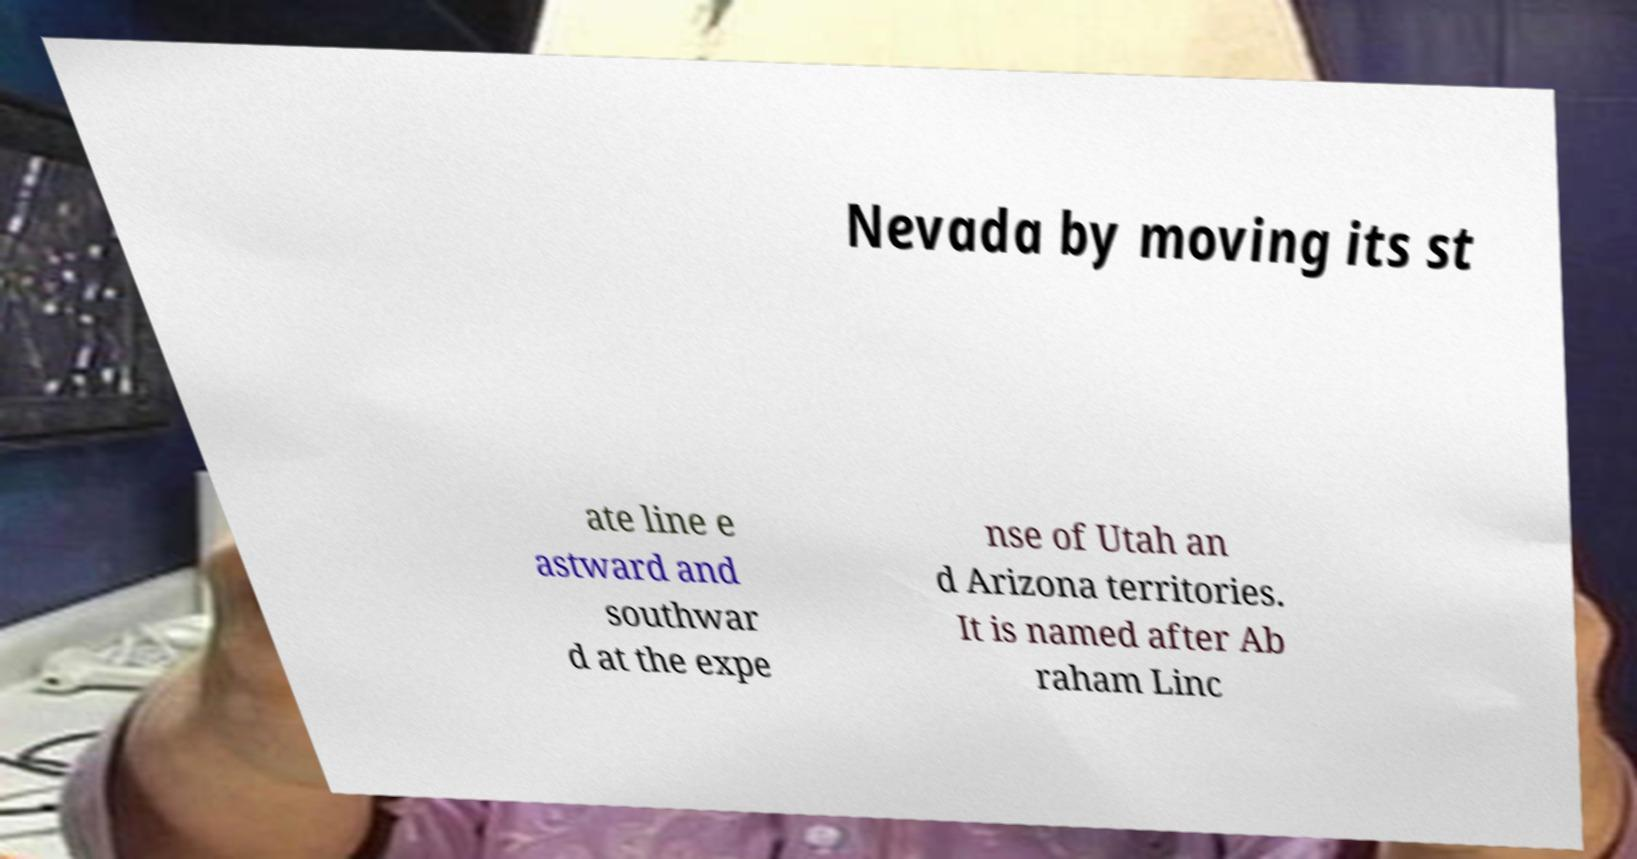For documentation purposes, I need the text within this image transcribed. Could you provide that? Nevada by moving its st ate line e astward and southwar d at the expe nse of Utah an d Arizona territories. It is named after Ab raham Linc 